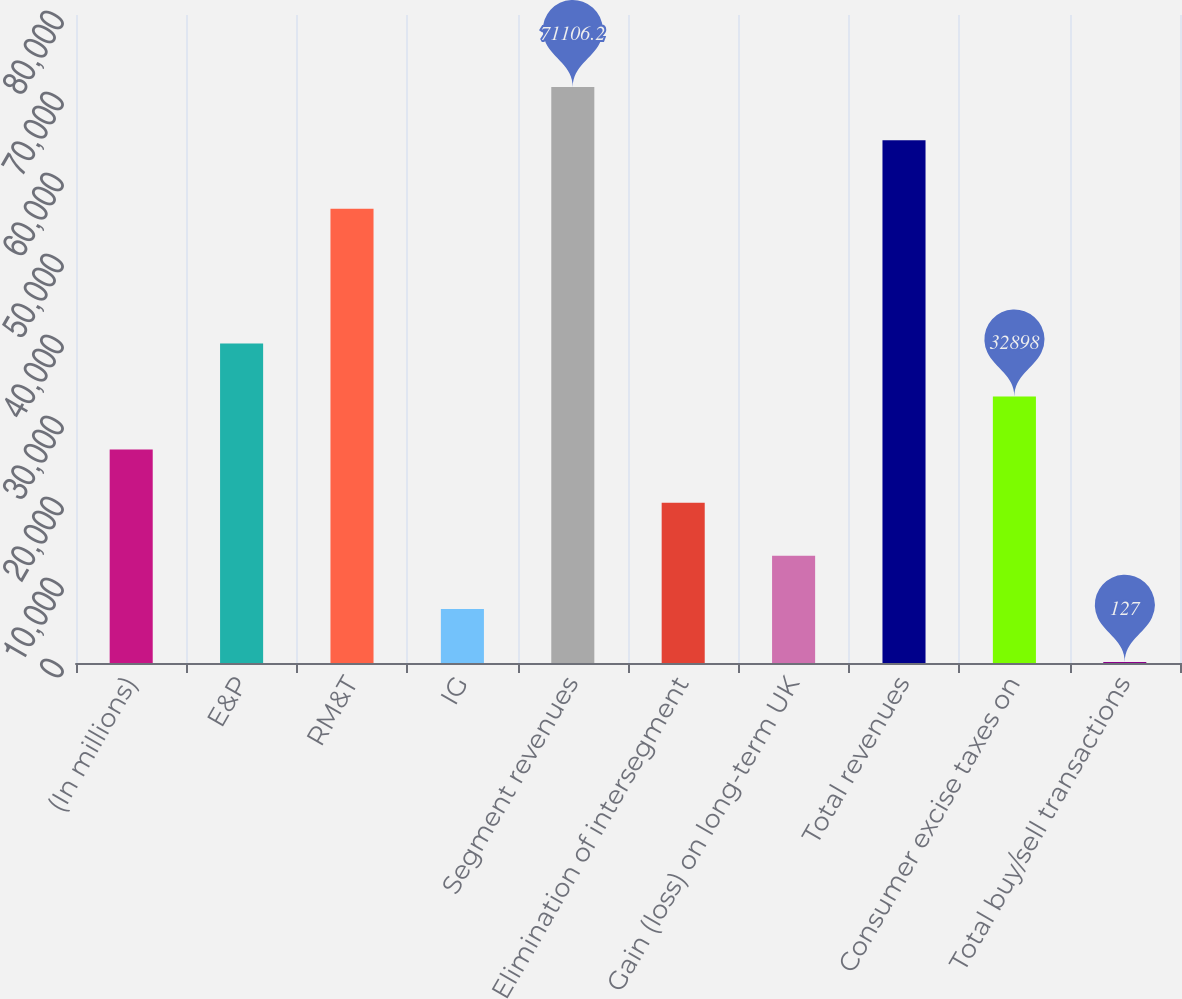Convert chart to OTSL. <chart><loc_0><loc_0><loc_500><loc_500><bar_chart><fcel>(In millions)<fcel>E&P<fcel>RM&T<fcel>IG<fcel>Segment revenues<fcel>Elimination of intersegment<fcel>Gain (loss) on long-term UK<fcel>Total revenues<fcel>Consumer excise taxes on<fcel>Total buy/sell transactions<nl><fcel>26343.8<fcel>39452.2<fcel>56075<fcel>6681.2<fcel>71106.2<fcel>19789.6<fcel>13235.4<fcel>64552<fcel>32898<fcel>127<nl></chart> 